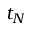Convert formula to latex. <formula><loc_0><loc_0><loc_500><loc_500>t _ { N }</formula> 